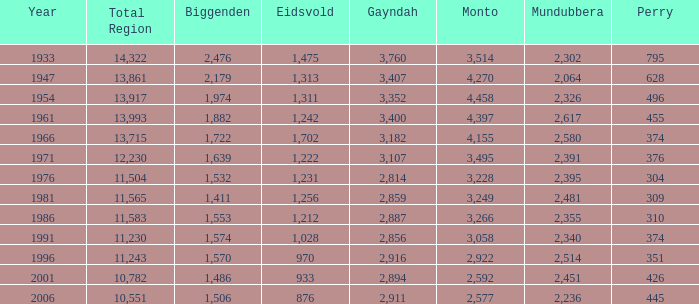What is the Total Region number of hte one that has Eidsvold at 970 and Biggenden larger than 1,570? 0.0. Can you parse all the data within this table? {'header': ['Year', 'Total Region', 'Biggenden', 'Eidsvold', 'Gayndah', 'Monto', 'Mundubbera', 'Perry'], 'rows': [['1933', '14,322', '2,476', '1,475', '3,760', '3,514', '2,302', '795'], ['1947', '13,861', '2,179', '1,313', '3,407', '4,270', '2,064', '628'], ['1954', '13,917', '1,974', '1,311', '3,352', '4,458', '2,326', '496'], ['1961', '13,993', '1,882', '1,242', '3,400', '4,397', '2,617', '455'], ['1966', '13,715', '1,722', '1,702', '3,182', '4,155', '2,580', '374'], ['1971', '12,230', '1,639', '1,222', '3,107', '3,495', '2,391', '376'], ['1976', '11,504', '1,532', '1,231', '2,814', '3,228', '2,395', '304'], ['1981', '11,565', '1,411', '1,256', '2,859', '3,249', '2,481', '309'], ['1986', '11,583', '1,553', '1,212', '2,887', '3,266', '2,355', '310'], ['1991', '11,230', '1,574', '1,028', '2,856', '3,058', '2,340', '374'], ['1996', '11,243', '1,570', '970', '2,916', '2,922', '2,514', '351'], ['2001', '10,782', '1,486', '933', '2,894', '2,592', '2,451', '426'], ['2006', '10,551', '1,506', '876', '2,911', '2,577', '2,236', '445']]} 